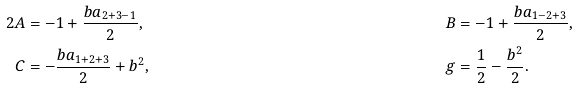<formula> <loc_0><loc_0><loc_500><loc_500>{ 2 } A & = - 1 + \frac { b a _ { 2 + 3 - 1 } } 2 , & \quad B & = - 1 + \frac { b a _ { 1 - 2 + 3 } } 2 , \\ C & = - \frac { b a _ { 1 + 2 + 3 } } 2 + b ^ { 2 } , & \quad g & = \frac { 1 } { 2 } - \frac { b ^ { 2 } } 2 .</formula> 